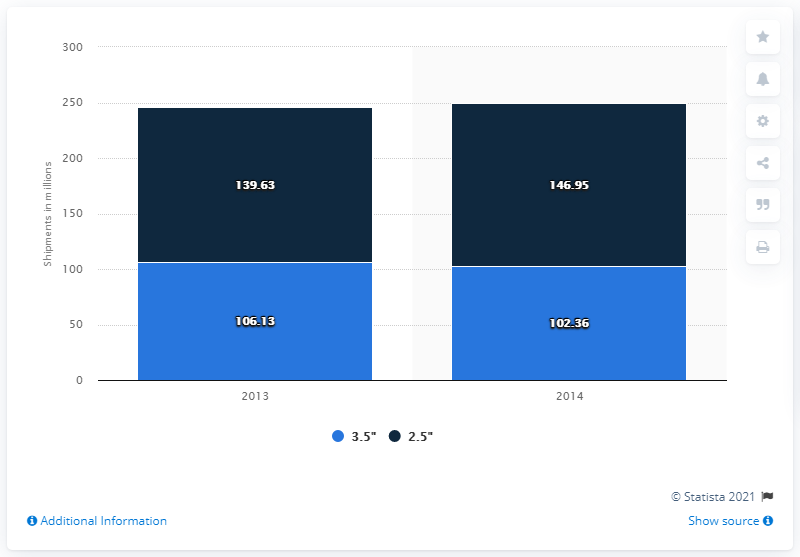Could you explain what might have influenced the changes in shipment volumes shown in the bar chart? Several factors could have influenced these changes, including market demand, technological advancements, and shifts in consumer preferences. For example, an increase in demand for larger-sized devices could explain the rise in shipments of 3.5" units, while the decrease in 2.5" units might suggest a shift towards alternative storage solutions or preferences for different device specifications. What further data might we want to analyze to better understand these trends? To gain a deeper understanding, we could look at the data on consumer purchasing patterns, the introduction of competing technologies like solid-state drives (SSDs), changes in pricing, industry supply chain factors, and global economic trends during the same period. Additionally, insights from industry reports and market analysis would provide a more comprehensive picture of the underlying causes of these trends. 